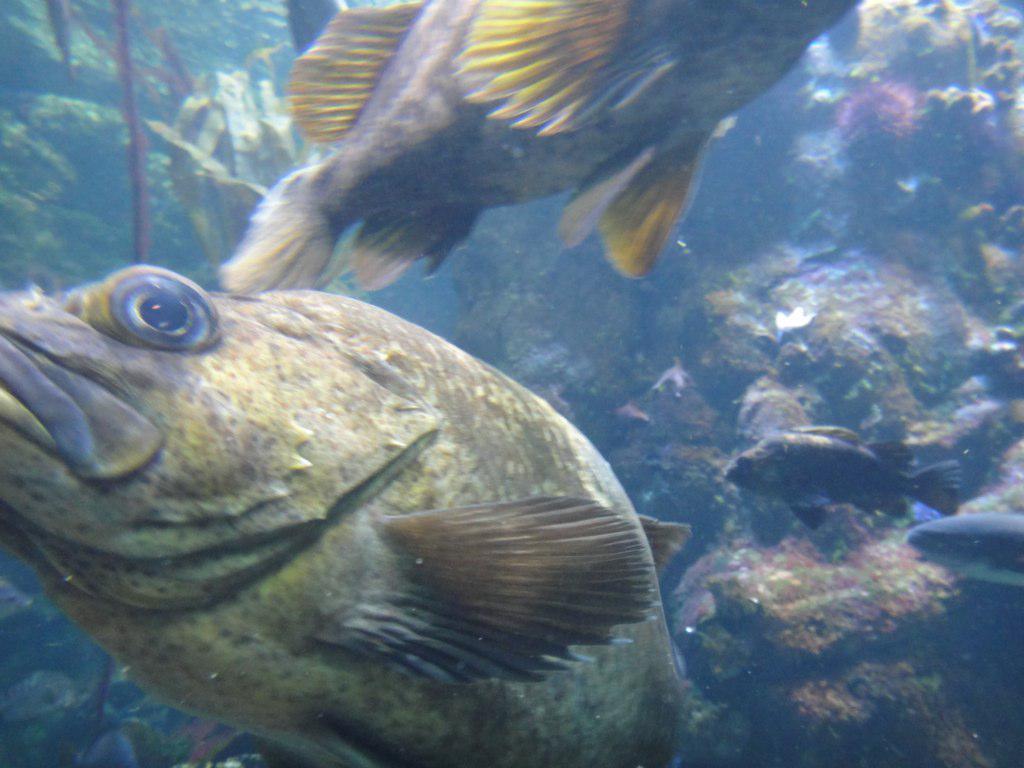Can you describe this image briefly? The picture is taken inside the water. In this picture there are fishes. In the background there are water objects, plants and rock. 